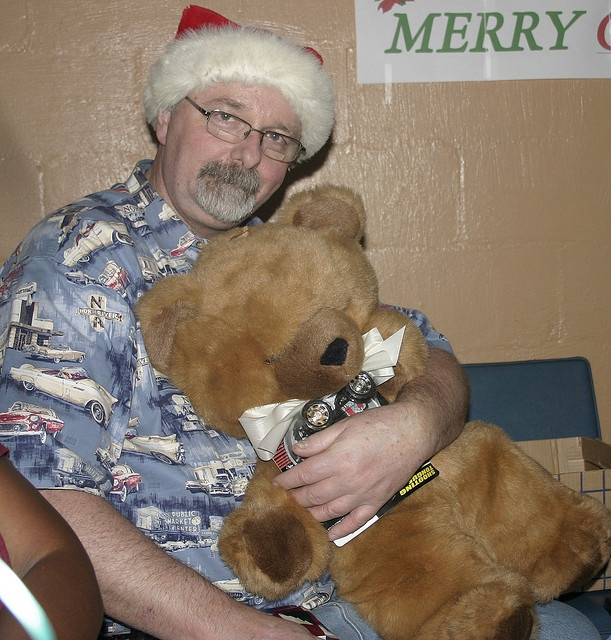Describe the objects in this image and their specific colors. I can see people in gray and darkgray tones, teddy bear in gray, maroon, and olive tones, people in gray, maroon, brown, and white tones, and bench in gray, darkblue, and black tones in this image. 